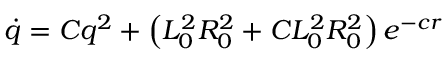<formula> <loc_0><loc_0><loc_500><loc_500>\dot { q } = C q ^ { 2 } + \left ( L _ { 0 } ^ { 2 } R _ { 0 } ^ { 2 } + C L _ { 0 } ^ { 2 } R _ { 0 } ^ { 2 } \right ) e ^ { - c r }</formula> 